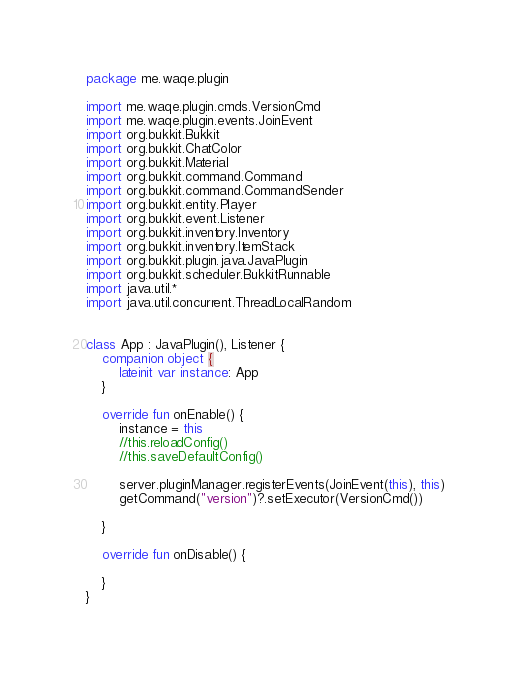<code> <loc_0><loc_0><loc_500><loc_500><_Kotlin_>package me.waqe.plugin

import me.waqe.plugin.cmds.VersionCmd
import me.waqe.plugin.events.JoinEvent
import org.bukkit.Bukkit
import org.bukkit.ChatColor
import org.bukkit.Material
import org.bukkit.command.Command
import org.bukkit.command.CommandSender
import org.bukkit.entity.Player
import org.bukkit.event.Listener
import org.bukkit.inventory.Inventory
import org.bukkit.inventory.ItemStack
import org.bukkit.plugin.java.JavaPlugin
import org.bukkit.scheduler.BukkitRunnable
import java.util.*
import java.util.concurrent.ThreadLocalRandom


class App : JavaPlugin(), Listener {
    companion object {
        lateinit var instance: App
    }

    override fun onEnable() {
        instance = this
        //this.reloadConfig()
        //this.saveDefaultConfig()

        server.pluginManager.registerEvents(JoinEvent(this), this)
        getCommand("version")?.setExecutor(VersionCmd())

    }

    override fun onDisable() {

    }
}
</code> 